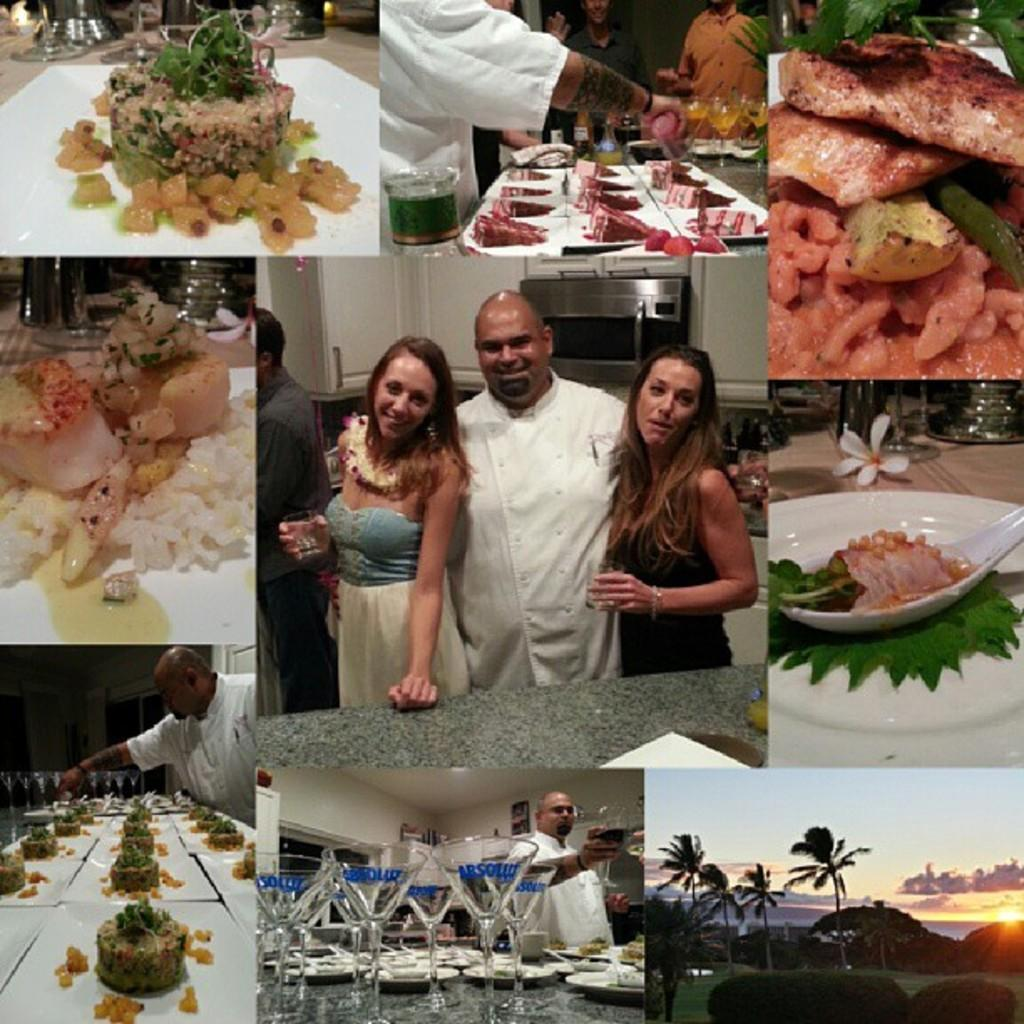What is the main subject of the image? The main subject of the image is a collage of different dishes of food items. How many people are in the image? There are three people in the image. What are the people doing in the image? The people are posing for the camera. What expressions do the people have on their faces? The people have smiles on their faces. What type of star can be seen in the lunchroom in the image? There is no mention of a star or a lunchroom in the image; it features a collage of food items and three people posing for the camera. 